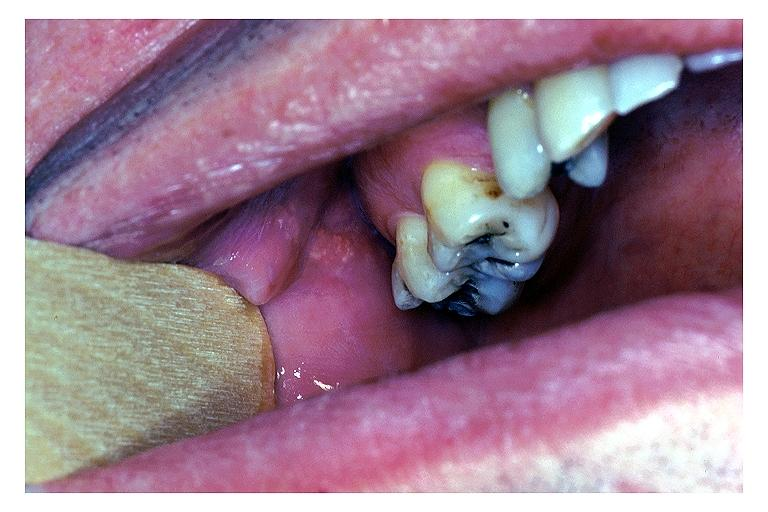does brain, cryptococcal meningitis, pas show fordyce granules?
Answer the question using a single word or phrase. No 